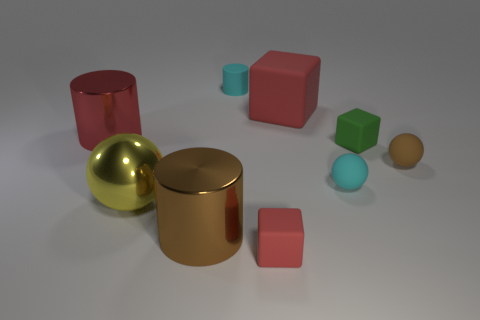Subtract all tiny matte cylinders. How many cylinders are left? 2 Add 1 small cyan things. How many objects exist? 10 Subtract all brown balls. How many balls are left? 2 Subtract all balls. How many objects are left? 6 Subtract 2 blocks. How many blocks are left? 1 Add 8 tiny brown matte objects. How many tiny brown matte objects are left? 9 Add 7 purple blocks. How many purple blocks exist? 7 Subtract 1 red cylinders. How many objects are left? 8 Subtract all blue cubes. Subtract all brown cylinders. How many cubes are left? 3 Subtract all cyan balls. How many green blocks are left? 1 